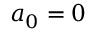<formula> <loc_0><loc_0><loc_500><loc_500>a _ { 0 } = 0</formula> 